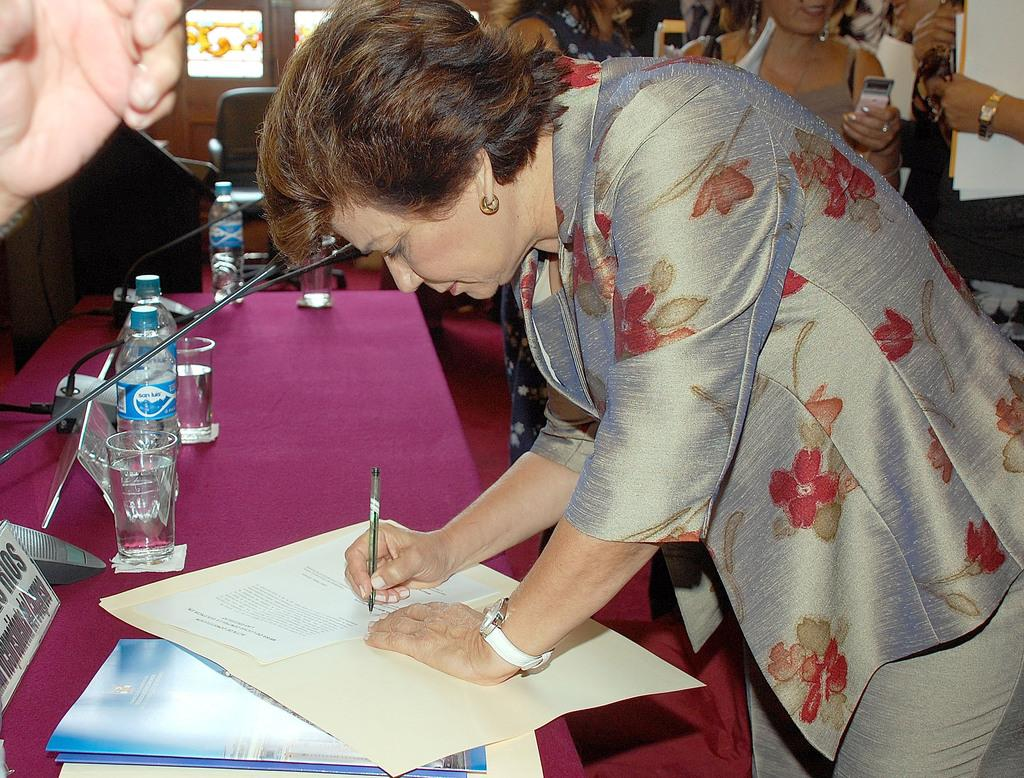Who is the person in the image? There is a woman in the image. What is the woman doing in the image? The woman is writing on a paper. What is the primary object in the image that the woman is using? There is a table in the image that the woman is using. What else can be seen on the table in the image? There are bottles and glasses on the table. Can you see any window shades in the image? There is no mention of window shades in the provided facts, and they are not visible in the image. 